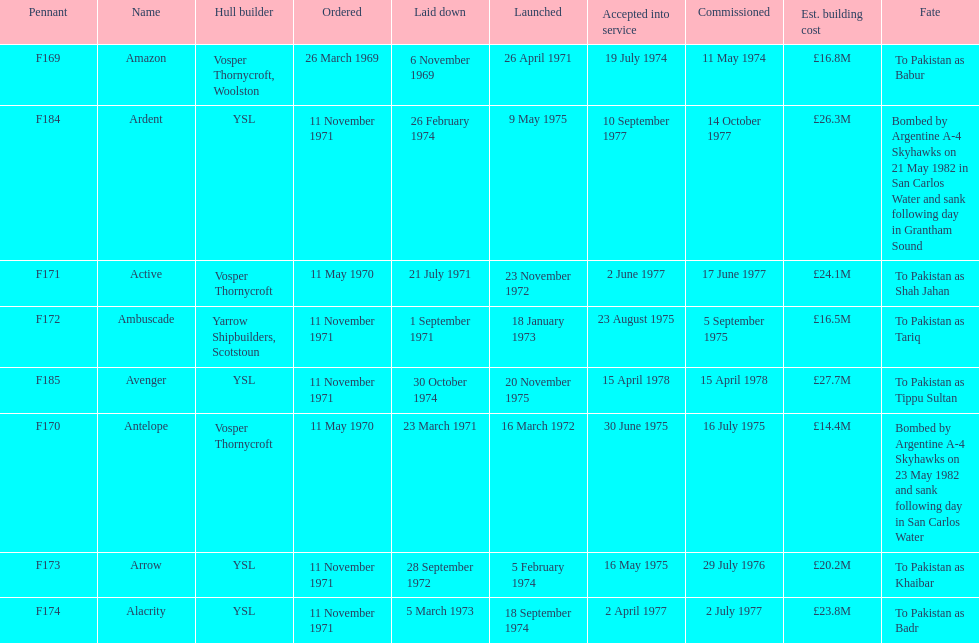Amazon is at the top of the chart, but what is the name below it? Antelope. 